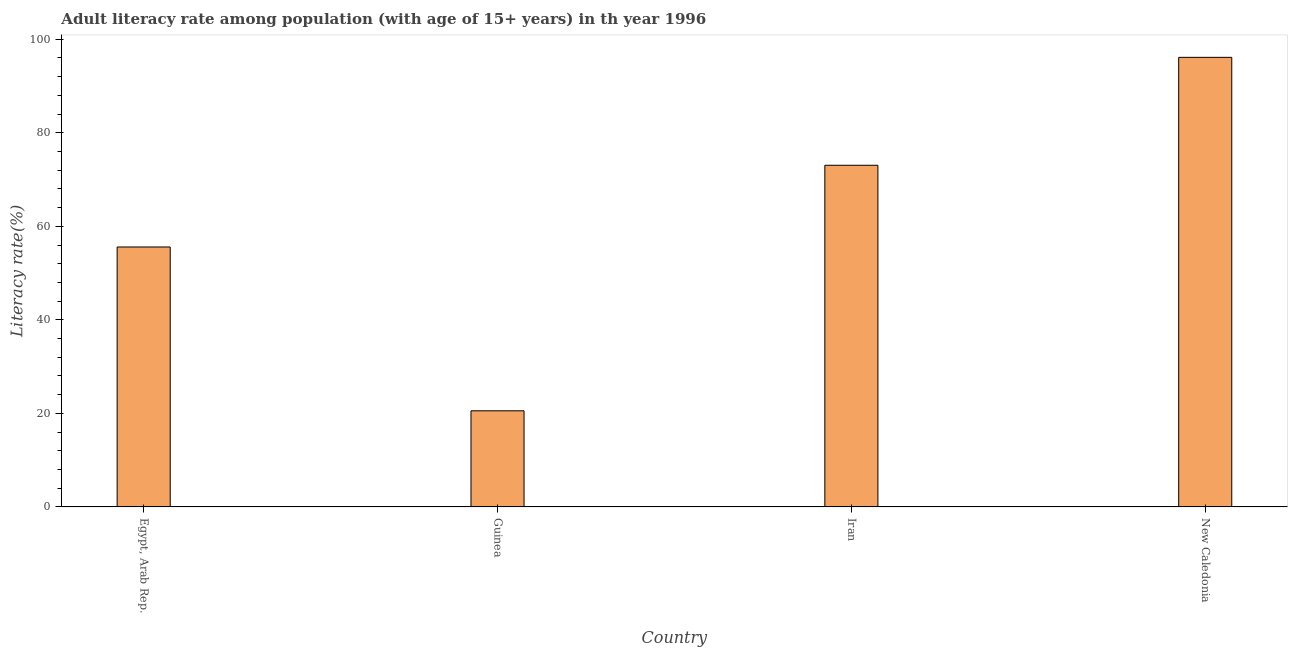Does the graph contain any zero values?
Keep it short and to the point. No. Does the graph contain grids?
Provide a succinct answer. No. What is the title of the graph?
Ensure brevity in your answer.  Adult literacy rate among population (with age of 15+ years) in th year 1996. What is the label or title of the Y-axis?
Keep it short and to the point. Literacy rate(%). What is the adult literacy rate in Egypt, Arab Rep.?
Make the answer very short. 55.59. Across all countries, what is the maximum adult literacy rate?
Provide a succinct answer. 96.14. Across all countries, what is the minimum adult literacy rate?
Your answer should be compact. 20.55. In which country was the adult literacy rate maximum?
Ensure brevity in your answer.  New Caledonia. In which country was the adult literacy rate minimum?
Ensure brevity in your answer.  Guinea. What is the sum of the adult literacy rate?
Give a very brief answer. 245.34. What is the difference between the adult literacy rate in Iran and New Caledonia?
Ensure brevity in your answer.  -23.08. What is the average adult literacy rate per country?
Ensure brevity in your answer.  61.34. What is the median adult literacy rate?
Make the answer very short. 64.32. What is the ratio of the adult literacy rate in Egypt, Arab Rep. to that in Iran?
Your answer should be very brief. 0.76. What is the difference between the highest and the second highest adult literacy rate?
Make the answer very short. 23.08. What is the difference between the highest and the lowest adult literacy rate?
Offer a terse response. 75.58. What is the Literacy rate(%) in Egypt, Arab Rep.?
Provide a short and direct response. 55.59. What is the Literacy rate(%) of Guinea?
Make the answer very short. 20.55. What is the Literacy rate(%) in Iran?
Provide a succinct answer. 73.06. What is the Literacy rate(%) of New Caledonia?
Provide a short and direct response. 96.14. What is the difference between the Literacy rate(%) in Egypt, Arab Rep. and Guinea?
Give a very brief answer. 35.03. What is the difference between the Literacy rate(%) in Egypt, Arab Rep. and Iran?
Offer a very short reply. -17.47. What is the difference between the Literacy rate(%) in Egypt, Arab Rep. and New Caledonia?
Keep it short and to the point. -40.55. What is the difference between the Literacy rate(%) in Guinea and Iran?
Your answer should be compact. -52.51. What is the difference between the Literacy rate(%) in Guinea and New Caledonia?
Your answer should be very brief. -75.58. What is the difference between the Literacy rate(%) in Iran and New Caledonia?
Provide a short and direct response. -23.08. What is the ratio of the Literacy rate(%) in Egypt, Arab Rep. to that in Guinea?
Your answer should be compact. 2.7. What is the ratio of the Literacy rate(%) in Egypt, Arab Rep. to that in Iran?
Your answer should be compact. 0.76. What is the ratio of the Literacy rate(%) in Egypt, Arab Rep. to that in New Caledonia?
Ensure brevity in your answer.  0.58. What is the ratio of the Literacy rate(%) in Guinea to that in Iran?
Provide a short and direct response. 0.28. What is the ratio of the Literacy rate(%) in Guinea to that in New Caledonia?
Ensure brevity in your answer.  0.21. What is the ratio of the Literacy rate(%) in Iran to that in New Caledonia?
Your answer should be very brief. 0.76. 